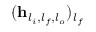<formula> <loc_0><loc_0><loc_500><loc_500>( h _ { l _ { i } , l _ { f } , l _ { o } } ) _ { l _ { f } }</formula> 